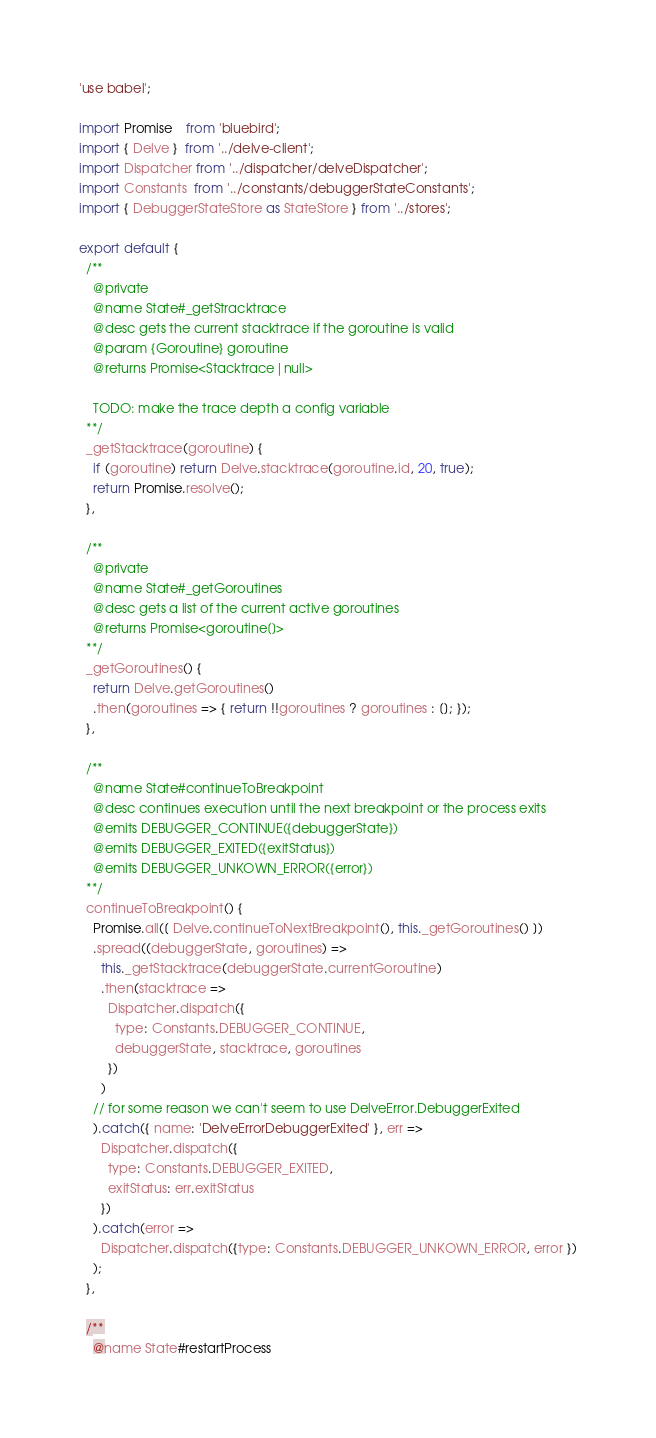Convert code to text. <code><loc_0><loc_0><loc_500><loc_500><_JavaScript_>'use babel';

import Promise    from 'bluebird';
import { Delve }  from '../delve-client';
import Dispatcher from '../dispatcher/delveDispatcher';
import Constants  from '../constants/debuggerStateConstants';
import { DebuggerStateStore as StateStore } from '../stores';

export default {
  /**
    @private
    @name State#_getStracktrace
    @desc gets the current stacktrace if the goroutine is valid
    @param {Goroutine} goroutine
    @returns Promise<Stacktrace|null>

    TODO: make the trace depth a config variable
  **/
  _getStacktrace(goroutine) {
    if (goroutine) return Delve.stacktrace(goroutine.id, 20, true);
    return Promise.resolve();
  },

  /**
    @private
    @name State#_getGoroutines
    @desc gets a list of the current active goroutines
    @returns Promise<goroutine[]>
  **/
  _getGoroutines() {
    return Delve.getGoroutines()
    .then(goroutines => { return !!goroutines ? goroutines : []; });
  },

  /**
    @name State#continueToBreakpoint
    @desc continues execution until the next breakpoint or the process exits
    @emits DEBUGGER_CONTINUE({debuggerState})
    @emits DEBUGGER_EXITED({exitStatus})
    @emits DEBUGGER_UNKOWN_ERROR({error})
  **/
  continueToBreakpoint() {
    Promise.all([ Delve.continueToNextBreakpoint(), this._getGoroutines() ])
    .spread((debuggerState, goroutines) =>
      this._getStacktrace(debuggerState.currentGoroutine)
      .then(stacktrace =>
        Dispatcher.dispatch({
          type: Constants.DEBUGGER_CONTINUE,
          debuggerState, stacktrace, goroutines
        })
      )
    // for some reason we can't seem to use DelveError.DebuggerExited
    ).catch({ name: 'DelveErrorDebuggerExited' }, err =>
      Dispatcher.dispatch({
        type: Constants.DEBUGGER_EXITED,
        exitStatus: err.exitStatus
      })
    ).catch(error =>
      Dispatcher.dispatch({type: Constants.DEBUGGER_UNKOWN_ERROR, error })
    );
  },

  /**
    @name State#restartProcess</code> 